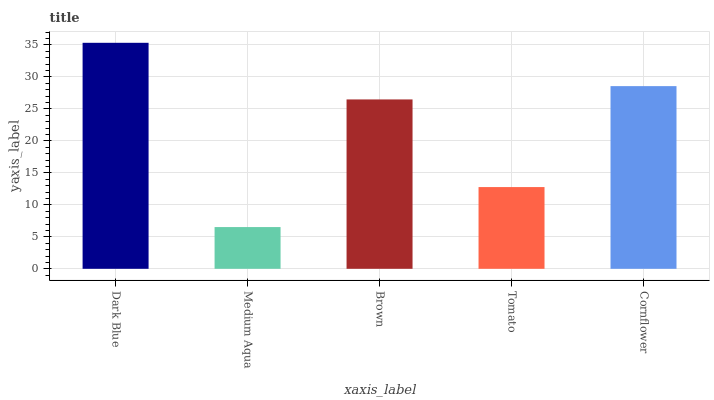Is Medium Aqua the minimum?
Answer yes or no. Yes. Is Dark Blue the maximum?
Answer yes or no. Yes. Is Brown the minimum?
Answer yes or no. No. Is Brown the maximum?
Answer yes or no. No. Is Brown greater than Medium Aqua?
Answer yes or no. Yes. Is Medium Aqua less than Brown?
Answer yes or no. Yes. Is Medium Aqua greater than Brown?
Answer yes or no. No. Is Brown less than Medium Aqua?
Answer yes or no. No. Is Brown the high median?
Answer yes or no. Yes. Is Brown the low median?
Answer yes or no. Yes. Is Cornflower the high median?
Answer yes or no. No. Is Medium Aqua the low median?
Answer yes or no. No. 